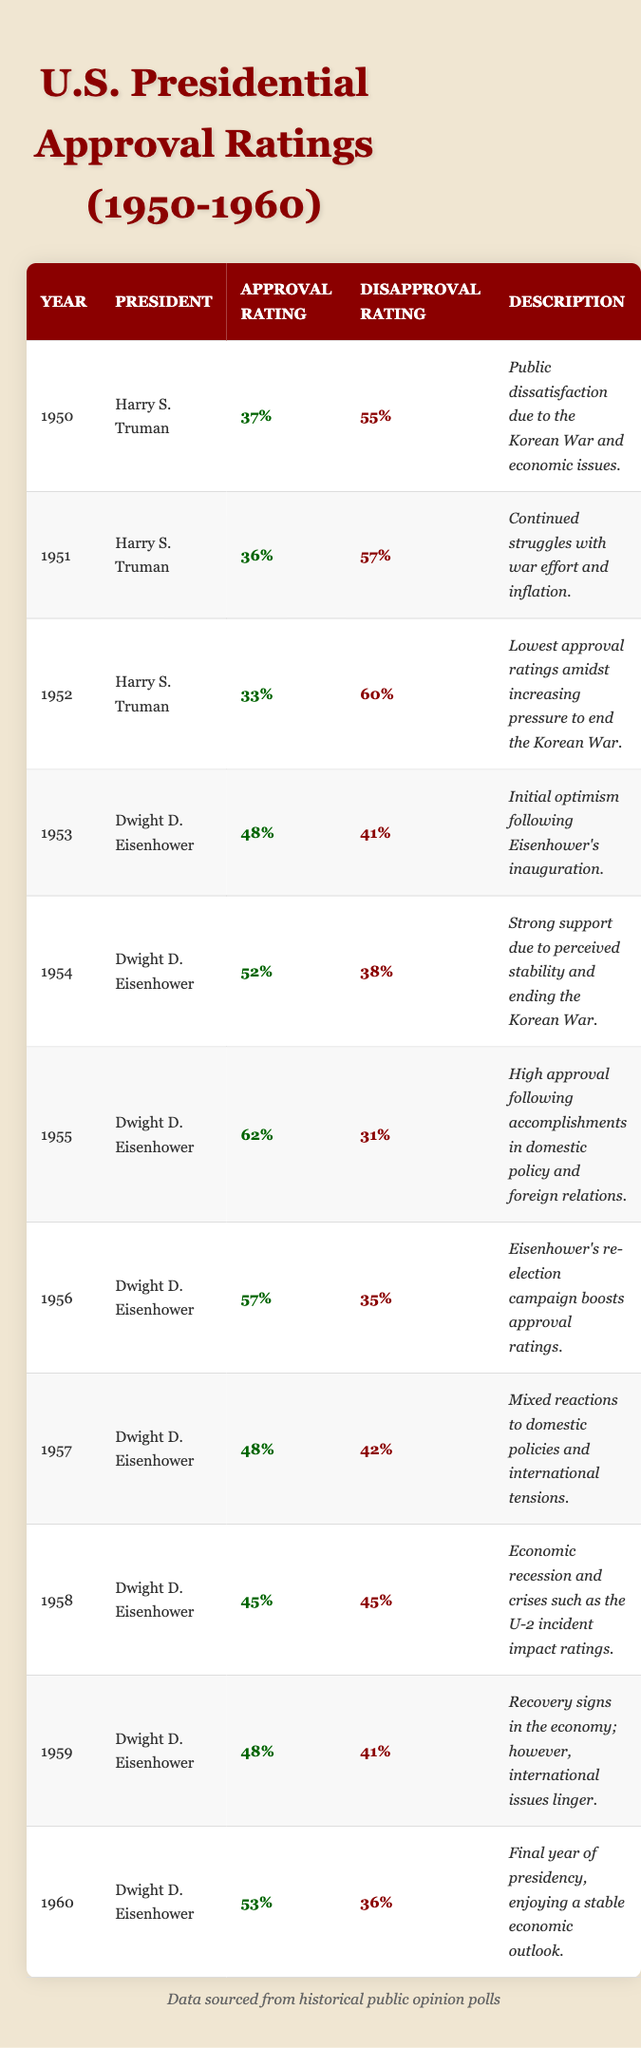What was the highest approval rating for Dwight D. Eisenhower during his presidency? The table shows Eisenhower's approval ratings from 1953 to 1960. The highest rating listed is 62% in 1955.
Answer: 62% What year saw the lowest approval rating for Harry S. Truman? In the table, Truman's approval ratings over the years are listed, with the lowest at 33% in 1952.
Answer: 1952 How many years did Dwight D. Eisenhower have an approval rating above 50%? By examining the ratings for Eisenhower from 1953 to 1960, he had approval ratings above 50% in 1954 (52%), 1955 (62%), and 1956 (57%), which totals three years.
Answer: 3 What was the average disapproval rating during Harry S. Truman's presidency from 1950 to 1952? Truman's disapproval ratings for the years 1950 (55%), 1951 (57%), and 1952 (60%) sum to 172%. Dividing 172% by 3 gives an average disapproval rating of 57.33%, which can be rounded to 57%.
Answer: 57% Did Dwight D. Eisenhower's approval rating ever drop below 45%? Looking at the table for Eisenhower's approval ratings from 1953 to 1960, the lowest is 45% in 1958. Thus, his approval rating was never below 45%.
Answer: No What trend can be observed in Truman's approval ratings from 1950 to 1952? The table shows a decrease in Truman's approval from 37% in 1950 to 33% in 1952, indicating a downward trend.
Answer: Downward trend What was the approval rating difference between the final year of Truman's presidency and the final year of Eisenhower's presidency? Truman's final approval rating in 1952 was 33%, and Eisenhower's final rating in 1960 was 53%. The difference is 53% - 33% = 20%.
Answer: 20% How did Eisenhower's approval rating in 1958 compare to the approval rating in 1955? In 1955, Eisenhower had an approval rating of 62%, while in 1958, it dropped to 45%. The decrease is 62% - 45% = 17%.
Answer: Decreased by 17% Which president had a higher overall average approval rating across the years provided? To find the overall average approval rating, calculate Truman's average (36.67%) from 1950 to 1952 and Eisenhower's average (50.67%) from 1953 to 1960. Eisenhower had a higher average approval rating.
Answer: Dwight D. Eisenhower Was there a year within the data where both presidents had an approval rating above 50%? The table shows that Eisenhower had approval ratings above 50% but Truman did not; hence, there was no overlap in those years where both had above 50%.
Answer: No 